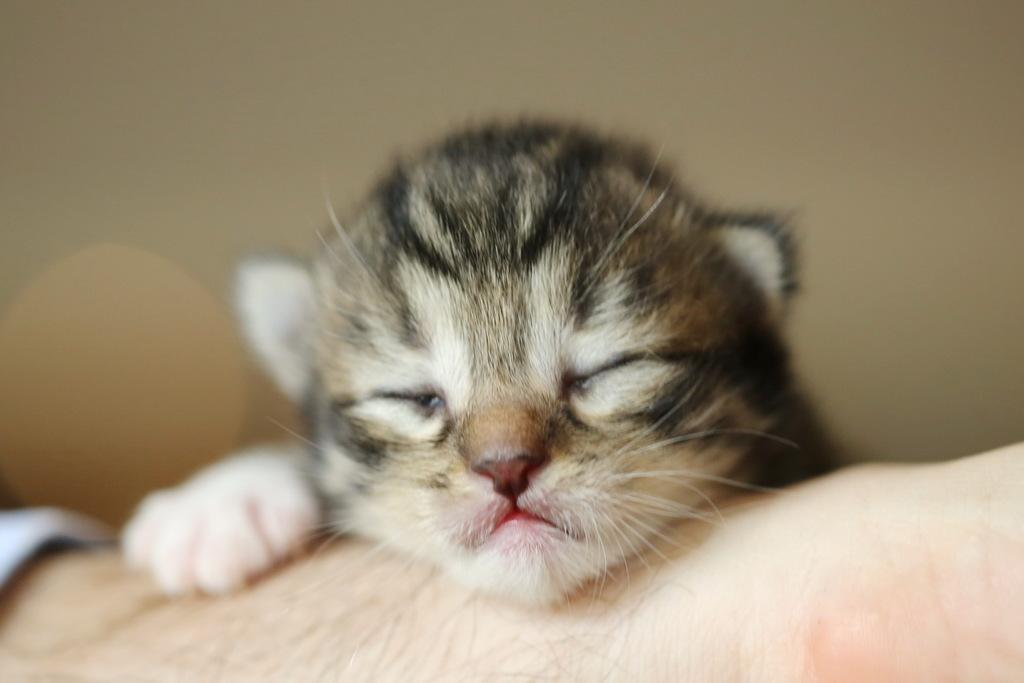What is the main subject in the center of the image? There is a cat in the center of the image. What part of a person can be seen in the image? A person's hand is visible at the bottom of the image. What type of structure is visible in the background of the image? There is a wall in the background of the image. What book is the cat reading in the image? There is no book or reading activity present in the image; it features a cat and a person's hand. 